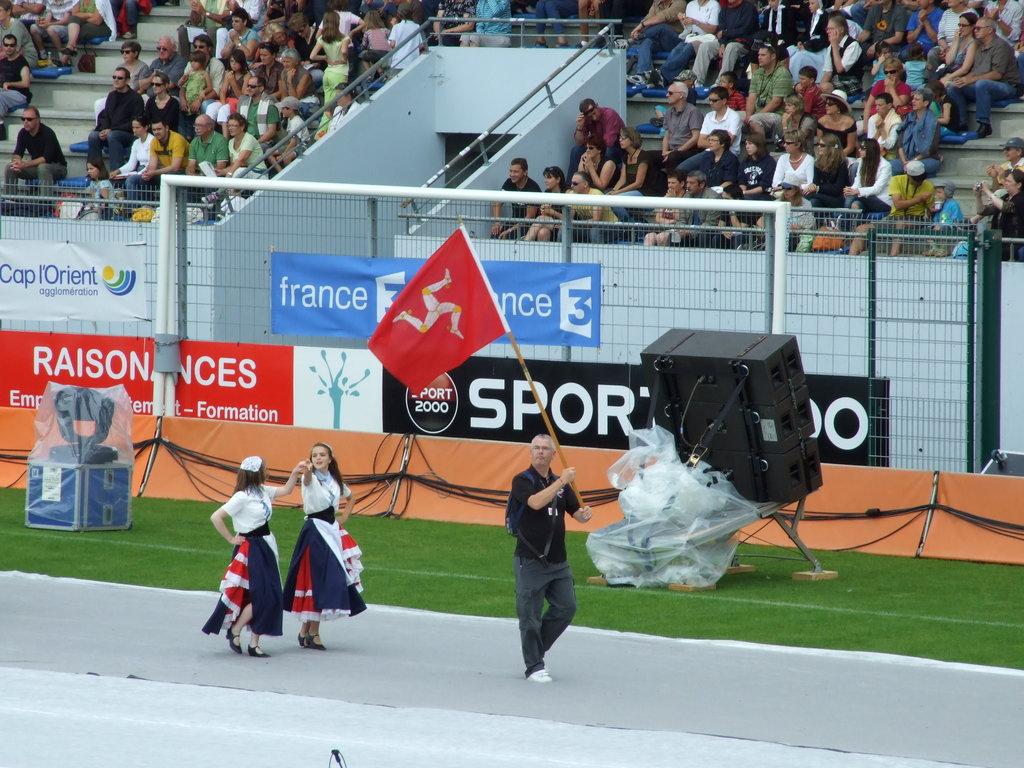Which country is named on the blue banner?
Your response must be concise. France. What letters are on the black banner?
Your answer should be compact. Sport 2000. 